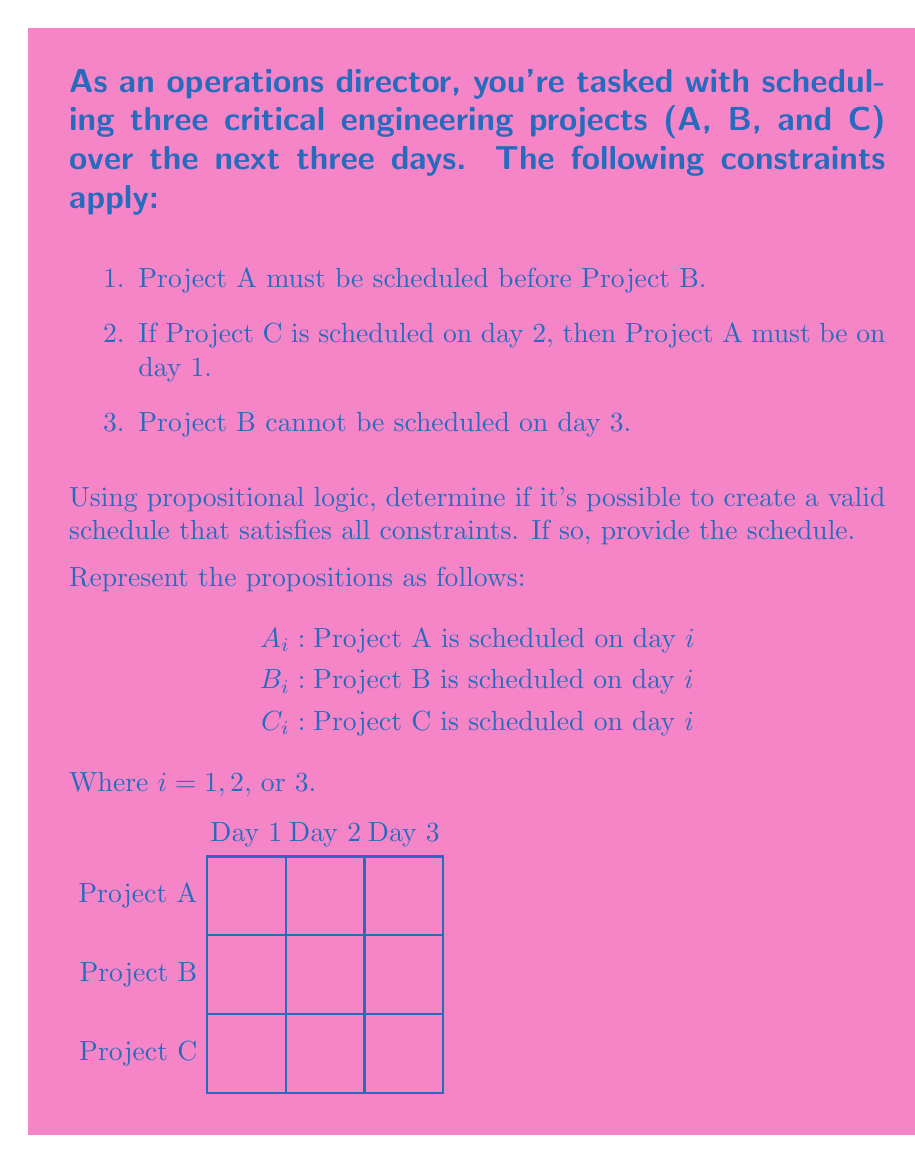Give your solution to this math problem. Let's approach this step-by-step using propositional logic:

1) First, let's express the given constraints in propositional logic:

   a. A before B: $(A_1 \wedge (B_2 \vee B_3)) \vee (A_2 \wedge B_3)$
   b. If C on day 2, then A on day 1: $C_2 \rightarrow A_1$
   c. B not on day 3: $\neg B_3$

2) We also need to ensure that each project is scheduled exactly once:

   $(A_1 \vee A_2 \vee A_3) \wedge (\neg A_1 \vee \neg A_2) \wedge (\neg A_1 \vee \neg A_3) \wedge (\neg A_2 \vee \neg A_3)$
   $(B_1 \vee B_2 \vee B_3) \wedge (\neg B_1 \vee \neg B_2) \wedge (\neg B_1 \vee \neg B_3) \wedge (\neg B_2 \vee \neg B_3)$
   $(C_1 \vee C_2 \vee C_3) \wedge (\neg C_1 \vee \neg C_2) \wedge (\neg C_1 \vee \neg C_3) \wedge (\neg C_2 \vee \neg C_3)$

3) Combining all these conditions, we get a complex propositional formula. To solve this, we can use a systematic approach or a SAT solver.

4) One valid solution that satisfies all constraints is:
   $A_1 \wedge B_2 \wedge C_3$

   This means:
   - Project A is scheduled on day 1
   - Project B is scheduled on day 2
   - Project C is scheduled on day 3

5) Let's verify this solution:
   - A is before B (constraint 1 satisfied)
   - C is not on day 2, so constraint 2 is trivially satisfied
   - B is not on day 3 (constraint 3 satisfied)
   - Each project is scheduled exactly once

Therefore, this is a valid schedule that satisfies all constraints.
Answer: Yes, valid schedule: A on day 1, B on day 2, C on day 3 